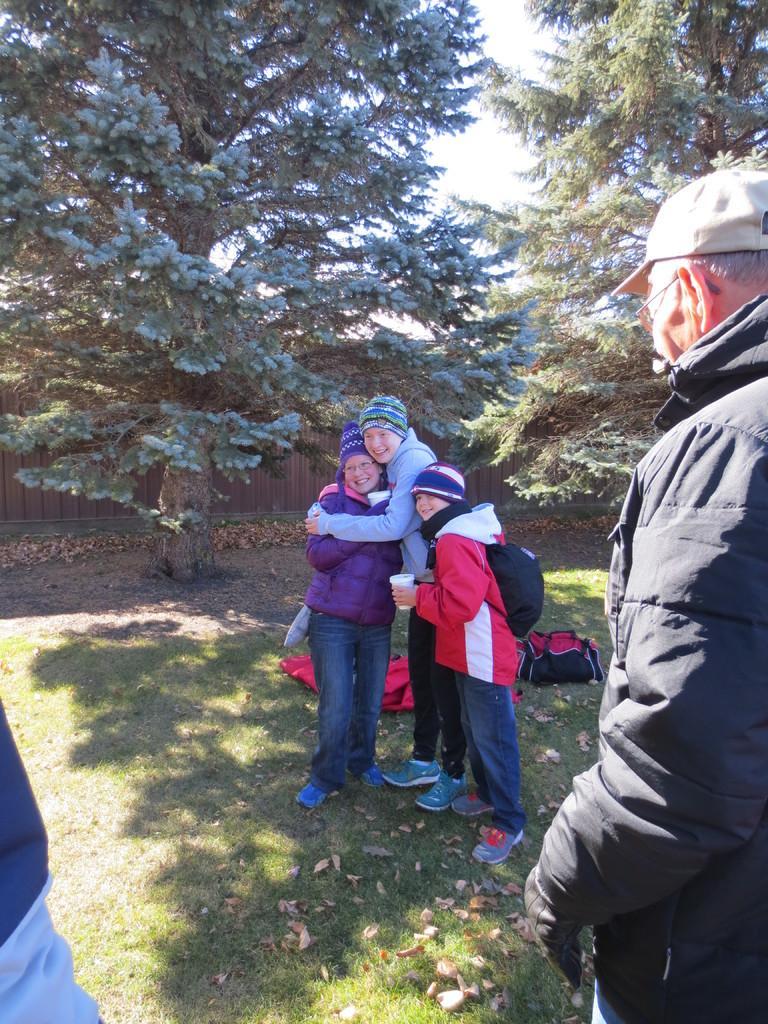Can you describe this image briefly? In this image there are persons standing and smiling and there are dry leaves on the ground. In the background there are trees and there are objects on the ground which are red and black in colour and there's grass on the ground. 